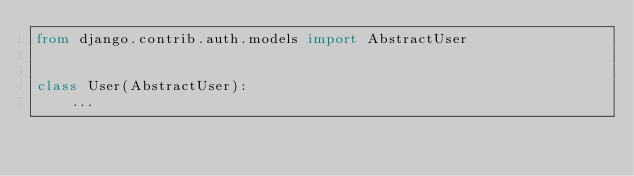<code> <loc_0><loc_0><loc_500><loc_500><_Python_>from django.contrib.auth.models import AbstractUser


class User(AbstractUser):
    ...
</code> 